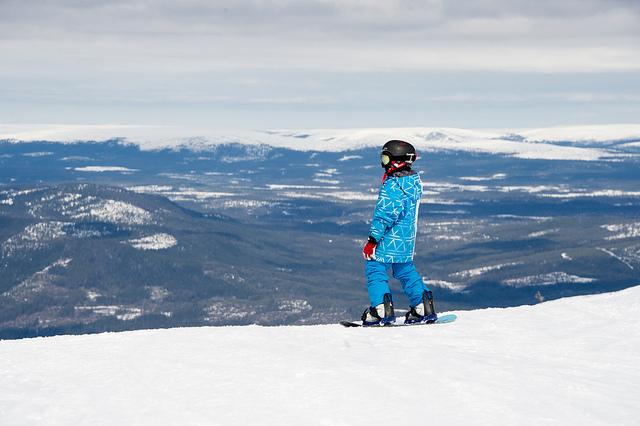Is he doing a trick?
Quick response, please. No. What is on the left hand?
Answer briefly. Glove. What is the person riding on?
Quick response, please. Snowboard. Is this person swimming?
Short answer required. No. 